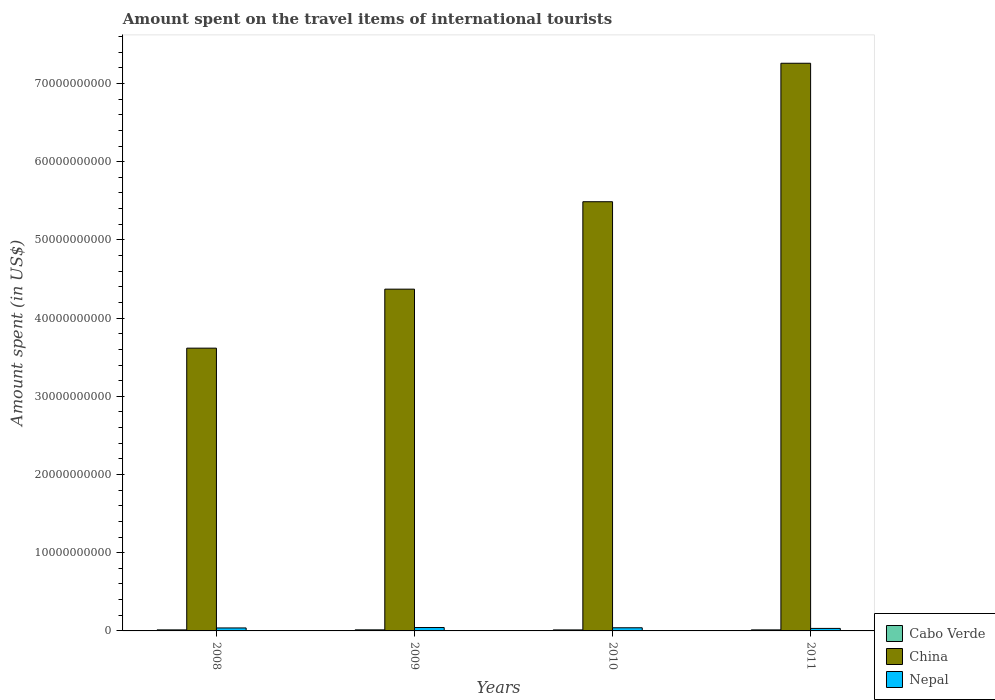Are the number of bars per tick equal to the number of legend labels?
Offer a terse response. Yes. How many bars are there on the 1st tick from the right?
Keep it short and to the point. 3. What is the amount spent on the travel items of international tourists in Cabo Verde in 2009?
Your response must be concise. 1.36e+08. Across all years, what is the maximum amount spent on the travel items of international tourists in Cabo Verde?
Provide a short and direct response. 1.36e+08. Across all years, what is the minimum amount spent on the travel items of international tourists in China?
Offer a very short reply. 3.62e+1. What is the total amount spent on the travel items of international tourists in Nepal in the graph?
Keep it short and to the point. 1.54e+09. What is the difference between the amount spent on the travel items of international tourists in China in 2008 and that in 2011?
Ensure brevity in your answer.  -3.64e+1. What is the difference between the amount spent on the travel items of international tourists in Cabo Verde in 2011 and the amount spent on the travel items of international tourists in Nepal in 2009?
Your answer should be compact. -3.02e+08. What is the average amount spent on the travel items of international tourists in Nepal per year?
Provide a succinct answer. 3.84e+08. In the year 2010, what is the difference between the amount spent on the travel items of international tourists in Cabo Verde and amount spent on the travel items of international tourists in Nepal?
Give a very brief answer. -2.73e+08. In how many years, is the amount spent on the travel items of international tourists in China greater than 16000000000 US$?
Give a very brief answer. 4. What is the ratio of the amount spent on the travel items of international tourists in Nepal in 2008 to that in 2009?
Make the answer very short. 0.88. Is the amount spent on the travel items of international tourists in Cabo Verde in 2010 less than that in 2011?
Give a very brief answer. Yes. What is the difference between the highest and the lowest amount spent on the travel items of international tourists in China?
Offer a very short reply. 3.64e+1. Is the sum of the amount spent on the travel items of international tourists in Cabo Verde in 2010 and 2011 greater than the maximum amount spent on the travel items of international tourists in China across all years?
Provide a short and direct response. No. What does the 1st bar from the left in 2009 represents?
Ensure brevity in your answer.  Cabo Verde. What does the 2nd bar from the right in 2010 represents?
Ensure brevity in your answer.  China. How many bars are there?
Ensure brevity in your answer.  12. How many years are there in the graph?
Provide a succinct answer. 4. Are the values on the major ticks of Y-axis written in scientific E-notation?
Offer a terse response. No. Does the graph contain any zero values?
Your answer should be compact. No. Where does the legend appear in the graph?
Keep it short and to the point. Bottom right. How are the legend labels stacked?
Your answer should be very brief. Vertical. What is the title of the graph?
Provide a short and direct response. Amount spent on the travel items of international tourists. What is the label or title of the Y-axis?
Provide a succinct answer. Amount spent (in US$). What is the Amount spent (in US$) in Cabo Verde in 2008?
Ensure brevity in your answer.  1.33e+08. What is the Amount spent (in US$) of China in 2008?
Your response must be concise. 3.62e+1. What is the Amount spent (in US$) of Nepal in 2008?
Make the answer very short. 3.81e+08. What is the Amount spent (in US$) in Cabo Verde in 2009?
Your response must be concise. 1.36e+08. What is the Amount spent (in US$) in China in 2009?
Your answer should be very brief. 4.37e+1. What is the Amount spent (in US$) of Nepal in 2009?
Offer a terse response. 4.34e+08. What is the Amount spent (in US$) in Cabo Verde in 2010?
Offer a very short reply. 1.29e+08. What is the Amount spent (in US$) in China in 2010?
Give a very brief answer. 5.49e+1. What is the Amount spent (in US$) in Nepal in 2010?
Provide a short and direct response. 4.02e+08. What is the Amount spent (in US$) of Cabo Verde in 2011?
Offer a terse response. 1.32e+08. What is the Amount spent (in US$) in China in 2011?
Your answer should be very brief. 7.26e+1. What is the Amount spent (in US$) of Nepal in 2011?
Offer a very short reply. 3.20e+08. Across all years, what is the maximum Amount spent (in US$) in Cabo Verde?
Keep it short and to the point. 1.36e+08. Across all years, what is the maximum Amount spent (in US$) in China?
Ensure brevity in your answer.  7.26e+1. Across all years, what is the maximum Amount spent (in US$) of Nepal?
Provide a succinct answer. 4.34e+08. Across all years, what is the minimum Amount spent (in US$) of Cabo Verde?
Your response must be concise. 1.29e+08. Across all years, what is the minimum Amount spent (in US$) in China?
Make the answer very short. 3.62e+1. Across all years, what is the minimum Amount spent (in US$) in Nepal?
Your response must be concise. 3.20e+08. What is the total Amount spent (in US$) of Cabo Verde in the graph?
Offer a very short reply. 5.30e+08. What is the total Amount spent (in US$) in China in the graph?
Provide a short and direct response. 2.07e+11. What is the total Amount spent (in US$) in Nepal in the graph?
Provide a short and direct response. 1.54e+09. What is the difference between the Amount spent (in US$) of Cabo Verde in 2008 and that in 2009?
Provide a short and direct response. -3.00e+06. What is the difference between the Amount spent (in US$) in China in 2008 and that in 2009?
Make the answer very short. -7.54e+09. What is the difference between the Amount spent (in US$) in Nepal in 2008 and that in 2009?
Keep it short and to the point. -5.30e+07. What is the difference between the Amount spent (in US$) in China in 2008 and that in 2010?
Your answer should be compact. -1.87e+1. What is the difference between the Amount spent (in US$) of Nepal in 2008 and that in 2010?
Your answer should be compact. -2.10e+07. What is the difference between the Amount spent (in US$) of Cabo Verde in 2008 and that in 2011?
Keep it short and to the point. 1.00e+06. What is the difference between the Amount spent (in US$) of China in 2008 and that in 2011?
Your answer should be compact. -3.64e+1. What is the difference between the Amount spent (in US$) in Nepal in 2008 and that in 2011?
Make the answer very short. 6.10e+07. What is the difference between the Amount spent (in US$) in China in 2009 and that in 2010?
Offer a very short reply. -1.12e+1. What is the difference between the Amount spent (in US$) in Nepal in 2009 and that in 2010?
Ensure brevity in your answer.  3.20e+07. What is the difference between the Amount spent (in US$) in China in 2009 and that in 2011?
Provide a short and direct response. -2.89e+1. What is the difference between the Amount spent (in US$) of Nepal in 2009 and that in 2011?
Your answer should be very brief. 1.14e+08. What is the difference between the Amount spent (in US$) of China in 2010 and that in 2011?
Provide a succinct answer. -1.77e+1. What is the difference between the Amount spent (in US$) in Nepal in 2010 and that in 2011?
Give a very brief answer. 8.20e+07. What is the difference between the Amount spent (in US$) of Cabo Verde in 2008 and the Amount spent (in US$) of China in 2009?
Make the answer very short. -4.36e+1. What is the difference between the Amount spent (in US$) in Cabo Verde in 2008 and the Amount spent (in US$) in Nepal in 2009?
Your answer should be compact. -3.01e+08. What is the difference between the Amount spent (in US$) in China in 2008 and the Amount spent (in US$) in Nepal in 2009?
Your answer should be very brief. 3.57e+1. What is the difference between the Amount spent (in US$) of Cabo Verde in 2008 and the Amount spent (in US$) of China in 2010?
Your response must be concise. -5.47e+1. What is the difference between the Amount spent (in US$) of Cabo Verde in 2008 and the Amount spent (in US$) of Nepal in 2010?
Provide a short and direct response. -2.69e+08. What is the difference between the Amount spent (in US$) in China in 2008 and the Amount spent (in US$) in Nepal in 2010?
Your answer should be very brief. 3.58e+1. What is the difference between the Amount spent (in US$) of Cabo Verde in 2008 and the Amount spent (in US$) of China in 2011?
Your answer should be compact. -7.25e+1. What is the difference between the Amount spent (in US$) of Cabo Verde in 2008 and the Amount spent (in US$) of Nepal in 2011?
Make the answer very short. -1.87e+08. What is the difference between the Amount spent (in US$) in China in 2008 and the Amount spent (in US$) in Nepal in 2011?
Your answer should be compact. 3.58e+1. What is the difference between the Amount spent (in US$) in Cabo Verde in 2009 and the Amount spent (in US$) in China in 2010?
Your answer should be compact. -5.47e+1. What is the difference between the Amount spent (in US$) in Cabo Verde in 2009 and the Amount spent (in US$) in Nepal in 2010?
Make the answer very short. -2.66e+08. What is the difference between the Amount spent (in US$) in China in 2009 and the Amount spent (in US$) in Nepal in 2010?
Give a very brief answer. 4.33e+1. What is the difference between the Amount spent (in US$) in Cabo Verde in 2009 and the Amount spent (in US$) in China in 2011?
Make the answer very short. -7.24e+1. What is the difference between the Amount spent (in US$) of Cabo Verde in 2009 and the Amount spent (in US$) of Nepal in 2011?
Your response must be concise. -1.84e+08. What is the difference between the Amount spent (in US$) of China in 2009 and the Amount spent (in US$) of Nepal in 2011?
Give a very brief answer. 4.34e+1. What is the difference between the Amount spent (in US$) of Cabo Verde in 2010 and the Amount spent (in US$) of China in 2011?
Your response must be concise. -7.25e+1. What is the difference between the Amount spent (in US$) of Cabo Verde in 2010 and the Amount spent (in US$) of Nepal in 2011?
Provide a short and direct response. -1.91e+08. What is the difference between the Amount spent (in US$) in China in 2010 and the Amount spent (in US$) in Nepal in 2011?
Ensure brevity in your answer.  5.46e+1. What is the average Amount spent (in US$) in Cabo Verde per year?
Your answer should be very brief. 1.32e+08. What is the average Amount spent (in US$) in China per year?
Provide a succinct answer. 5.18e+1. What is the average Amount spent (in US$) of Nepal per year?
Make the answer very short. 3.84e+08. In the year 2008, what is the difference between the Amount spent (in US$) of Cabo Verde and Amount spent (in US$) of China?
Provide a succinct answer. -3.60e+1. In the year 2008, what is the difference between the Amount spent (in US$) of Cabo Verde and Amount spent (in US$) of Nepal?
Your answer should be very brief. -2.48e+08. In the year 2008, what is the difference between the Amount spent (in US$) in China and Amount spent (in US$) in Nepal?
Your response must be concise. 3.58e+1. In the year 2009, what is the difference between the Amount spent (in US$) of Cabo Verde and Amount spent (in US$) of China?
Offer a very short reply. -4.36e+1. In the year 2009, what is the difference between the Amount spent (in US$) in Cabo Verde and Amount spent (in US$) in Nepal?
Offer a terse response. -2.98e+08. In the year 2009, what is the difference between the Amount spent (in US$) of China and Amount spent (in US$) of Nepal?
Your answer should be compact. 4.33e+1. In the year 2010, what is the difference between the Amount spent (in US$) in Cabo Verde and Amount spent (in US$) in China?
Your response must be concise. -5.48e+1. In the year 2010, what is the difference between the Amount spent (in US$) of Cabo Verde and Amount spent (in US$) of Nepal?
Make the answer very short. -2.73e+08. In the year 2010, what is the difference between the Amount spent (in US$) in China and Amount spent (in US$) in Nepal?
Keep it short and to the point. 5.45e+1. In the year 2011, what is the difference between the Amount spent (in US$) of Cabo Verde and Amount spent (in US$) of China?
Ensure brevity in your answer.  -7.25e+1. In the year 2011, what is the difference between the Amount spent (in US$) in Cabo Verde and Amount spent (in US$) in Nepal?
Keep it short and to the point. -1.88e+08. In the year 2011, what is the difference between the Amount spent (in US$) in China and Amount spent (in US$) in Nepal?
Ensure brevity in your answer.  7.23e+1. What is the ratio of the Amount spent (in US$) in Cabo Verde in 2008 to that in 2009?
Your answer should be very brief. 0.98. What is the ratio of the Amount spent (in US$) of China in 2008 to that in 2009?
Your answer should be compact. 0.83. What is the ratio of the Amount spent (in US$) in Nepal in 2008 to that in 2009?
Make the answer very short. 0.88. What is the ratio of the Amount spent (in US$) of Cabo Verde in 2008 to that in 2010?
Your answer should be compact. 1.03. What is the ratio of the Amount spent (in US$) of China in 2008 to that in 2010?
Your answer should be compact. 0.66. What is the ratio of the Amount spent (in US$) of Nepal in 2008 to that in 2010?
Give a very brief answer. 0.95. What is the ratio of the Amount spent (in US$) in Cabo Verde in 2008 to that in 2011?
Offer a very short reply. 1.01. What is the ratio of the Amount spent (in US$) of China in 2008 to that in 2011?
Keep it short and to the point. 0.5. What is the ratio of the Amount spent (in US$) in Nepal in 2008 to that in 2011?
Offer a terse response. 1.19. What is the ratio of the Amount spent (in US$) in Cabo Verde in 2009 to that in 2010?
Make the answer very short. 1.05. What is the ratio of the Amount spent (in US$) of China in 2009 to that in 2010?
Provide a short and direct response. 0.8. What is the ratio of the Amount spent (in US$) of Nepal in 2009 to that in 2010?
Your answer should be very brief. 1.08. What is the ratio of the Amount spent (in US$) of Cabo Verde in 2009 to that in 2011?
Offer a terse response. 1.03. What is the ratio of the Amount spent (in US$) in China in 2009 to that in 2011?
Offer a terse response. 0.6. What is the ratio of the Amount spent (in US$) of Nepal in 2009 to that in 2011?
Offer a terse response. 1.36. What is the ratio of the Amount spent (in US$) in Cabo Verde in 2010 to that in 2011?
Give a very brief answer. 0.98. What is the ratio of the Amount spent (in US$) in China in 2010 to that in 2011?
Your response must be concise. 0.76. What is the ratio of the Amount spent (in US$) in Nepal in 2010 to that in 2011?
Your answer should be compact. 1.26. What is the difference between the highest and the second highest Amount spent (in US$) in Cabo Verde?
Make the answer very short. 3.00e+06. What is the difference between the highest and the second highest Amount spent (in US$) of China?
Your answer should be compact. 1.77e+1. What is the difference between the highest and the second highest Amount spent (in US$) in Nepal?
Keep it short and to the point. 3.20e+07. What is the difference between the highest and the lowest Amount spent (in US$) in China?
Give a very brief answer. 3.64e+1. What is the difference between the highest and the lowest Amount spent (in US$) of Nepal?
Ensure brevity in your answer.  1.14e+08. 